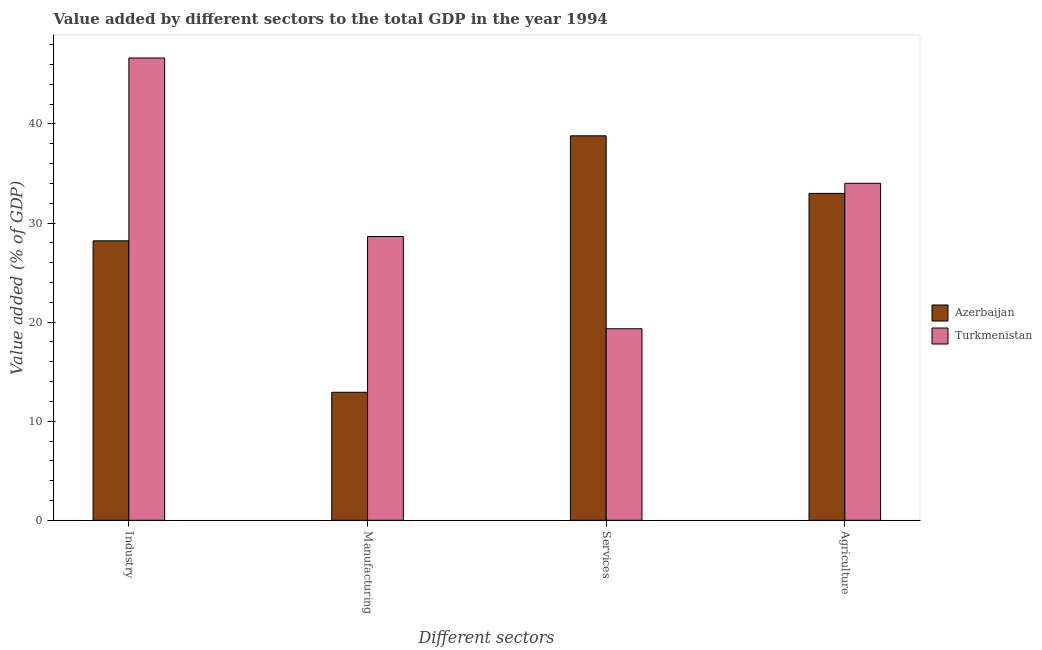How many different coloured bars are there?
Ensure brevity in your answer.  2. How many groups of bars are there?
Provide a short and direct response. 4. Are the number of bars on each tick of the X-axis equal?
Provide a short and direct response. Yes. What is the label of the 1st group of bars from the left?
Offer a terse response. Industry. What is the value added by industrial sector in Turkmenistan?
Keep it short and to the point. 46.66. Across all countries, what is the maximum value added by industrial sector?
Provide a short and direct response. 46.66. Across all countries, what is the minimum value added by agricultural sector?
Your response must be concise. 32.99. In which country was the value added by agricultural sector maximum?
Give a very brief answer. Turkmenistan. In which country was the value added by industrial sector minimum?
Keep it short and to the point. Azerbaijan. What is the total value added by industrial sector in the graph?
Ensure brevity in your answer.  74.86. What is the difference between the value added by agricultural sector in Azerbaijan and that in Turkmenistan?
Ensure brevity in your answer.  -1.02. What is the difference between the value added by agricultural sector in Turkmenistan and the value added by manufacturing sector in Azerbaijan?
Offer a very short reply. 21.09. What is the average value added by agricultural sector per country?
Your answer should be very brief. 33.5. What is the difference between the value added by industrial sector and value added by agricultural sector in Azerbaijan?
Ensure brevity in your answer.  -4.79. In how many countries, is the value added by agricultural sector greater than 22 %?
Keep it short and to the point. 2. What is the ratio of the value added by agricultural sector in Azerbaijan to that in Turkmenistan?
Provide a short and direct response. 0.97. Is the difference between the value added by industrial sector in Turkmenistan and Azerbaijan greater than the difference between the value added by manufacturing sector in Turkmenistan and Azerbaijan?
Offer a terse response. Yes. What is the difference between the highest and the second highest value added by industrial sector?
Ensure brevity in your answer.  18.45. What is the difference between the highest and the lowest value added by services sector?
Keep it short and to the point. 19.47. Is the sum of the value added by agricultural sector in Turkmenistan and Azerbaijan greater than the maximum value added by industrial sector across all countries?
Offer a terse response. Yes. What does the 1st bar from the left in Agriculture represents?
Ensure brevity in your answer.  Azerbaijan. What does the 1st bar from the right in Industry represents?
Your answer should be very brief. Turkmenistan. How many bars are there?
Provide a succinct answer. 8. Are all the bars in the graph horizontal?
Provide a short and direct response. No. How many countries are there in the graph?
Ensure brevity in your answer.  2. Are the values on the major ticks of Y-axis written in scientific E-notation?
Give a very brief answer. No. Where does the legend appear in the graph?
Your answer should be compact. Center right. How many legend labels are there?
Your answer should be very brief. 2. What is the title of the graph?
Give a very brief answer. Value added by different sectors to the total GDP in the year 1994. Does "Kuwait" appear as one of the legend labels in the graph?
Your response must be concise. No. What is the label or title of the X-axis?
Make the answer very short. Different sectors. What is the label or title of the Y-axis?
Offer a very short reply. Value added (% of GDP). What is the Value added (% of GDP) in Azerbaijan in Industry?
Give a very brief answer. 28.2. What is the Value added (% of GDP) in Turkmenistan in Industry?
Make the answer very short. 46.66. What is the Value added (% of GDP) in Azerbaijan in Manufacturing?
Your answer should be very brief. 12.92. What is the Value added (% of GDP) in Turkmenistan in Manufacturing?
Offer a terse response. 28.64. What is the Value added (% of GDP) of Azerbaijan in Services?
Your answer should be compact. 38.8. What is the Value added (% of GDP) in Turkmenistan in Services?
Provide a short and direct response. 19.33. What is the Value added (% of GDP) in Azerbaijan in Agriculture?
Provide a short and direct response. 32.99. What is the Value added (% of GDP) in Turkmenistan in Agriculture?
Your answer should be compact. 34.01. Across all Different sectors, what is the maximum Value added (% of GDP) of Azerbaijan?
Your answer should be very brief. 38.8. Across all Different sectors, what is the maximum Value added (% of GDP) in Turkmenistan?
Your response must be concise. 46.66. Across all Different sectors, what is the minimum Value added (% of GDP) in Azerbaijan?
Provide a succinct answer. 12.92. Across all Different sectors, what is the minimum Value added (% of GDP) in Turkmenistan?
Make the answer very short. 19.33. What is the total Value added (% of GDP) of Azerbaijan in the graph?
Keep it short and to the point. 112.92. What is the total Value added (% of GDP) of Turkmenistan in the graph?
Your response must be concise. 128.64. What is the difference between the Value added (% of GDP) in Azerbaijan in Industry and that in Manufacturing?
Provide a succinct answer. 15.29. What is the difference between the Value added (% of GDP) in Turkmenistan in Industry and that in Manufacturing?
Your response must be concise. 18.02. What is the difference between the Value added (% of GDP) of Azerbaijan in Industry and that in Services?
Your answer should be very brief. -10.6. What is the difference between the Value added (% of GDP) of Turkmenistan in Industry and that in Services?
Your answer should be compact. 27.33. What is the difference between the Value added (% of GDP) of Azerbaijan in Industry and that in Agriculture?
Make the answer very short. -4.79. What is the difference between the Value added (% of GDP) in Turkmenistan in Industry and that in Agriculture?
Your response must be concise. 12.65. What is the difference between the Value added (% of GDP) in Azerbaijan in Manufacturing and that in Services?
Offer a very short reply. -25.89. What is the difference between the Value added (% of GDP) of Turkmenistan in Manufacturing and that in Services?
Offer a terse response. 9.31. What is the difference between the Value added (% of GDP) of Azerbaijan in Manufacturing and that in Agriculture?
Your answer should be very brief. -20.07. What is the difference between the Value added (% of GDP) in Turkmenistan in Manufacturing and that in Agriculture?
Offer a terse response. -5.37. What is the difference between the Value added (% of GDP) of Azerbaijan in Services and that in Agriculture?
Provide a succinct answer. 5.81. What is the difference between the Value added (% of GDP) of Turkmenistan in Services and that in Agriculture?
Ensure brevity in your answer.  -14.68. What is the difference between the Value added (% of GDP) of Azerbaijan in Industry and the Value added (% of GDP) of Turkmenistan in Manufacturing?
Keep it short and to the point. -0.43. What is the difference between the Value added (% of GDP) in Azerbaijan in Industry and the Value added (% of GDP) in Turkmenistan in Services?
Make the answer very short. 8.87. What is the difference between the Value added (% of GDP) of Azerbaijan in Industry and the Value added (% of GDP) of Turkmenistan in Agriculture?
Your answer should be very brief. -5.8. What is the difference between the Value added (% of GDP) in Azerbaijan in Manufacturing and the Value added (% of GDP) in Turkmenistan in Services?
Make the answer very short. -6.41. What is the difference between the Value added (% of GDP) of Azerbaijan in Manufacturing and the Value added (% of GDP) of Turkmenistan in Agriculture?
Your response must be concise. -21.09. What is the difference between the Value added (% of GDP) in Azerbaijan in Services and the Value added (% of GDP) in Turkmenistan in Agriculture?
Keep it short and to the point. 4.79. What is the average Value added (% of GDP) in Azerbaijan per Different sectors?
Offer a very short reply. 28.23. What is the average Value added (% of GDP) in Turkmenistan per Different sectors?
Your response must be concise. 32.16. What is the difference between the Value added (% of GDP) in Azerbaijan and Value added (% of GDP) in Turkmenistan in Industry?
Your answer should be very brief. -18.45. What is the difference between the Value added (% of GDP) in Azerbaijan and Value added (% of GDP) in Turkmenistan in Manufacturing?
Provide a succinct answer. -15.72. What is the difference between the Value added (% of GDP) of Azerbaijan and Value added (% of GDP) of Turkmenistan in Services?
Keep it short and to the point. 19.47. What is the difference between the Value added (% of GDP) in Azerbaijan and Value added (% of GDP) in Turkmenistan in Agriculture?
Your answer should be compact. -1.02. What is the ratio of the Value added (% of GDP) of Azerbaijan in Industry to that in Manufacturing?
Your response must be concise. 2.18. What is the ratio of the Value added (% of GDP) of Turkmenistan in Industry to that in Manufacturing?
Keep it short and to the point. 1.63. What is the ratio of the Value added (% of GDP) of Azerbaijan in Industry to that in Services?
Provide a succinct answer. 0.73. What is the ratio of the Value added (% of GDP) of Turkmenistan in Industry to that in Services?
Provide a short and direct response. 2.41. What is the ratio of the Value added (% of GDP) in Azerbaijan in Industry to that in Agriculture?
Offer a terse response. 0.85. What is the ratio of the Value added (% of GDP) of Turkmenistan in Industry to that in Agriculture?
Your answer should be compact. 1.37. What is the ratio of the Value added (% of GDP) of Azerbaijan in Manufacturing to that in Services?
Ensure brevity in your answer.  0.33. What is the ratio of the Value added (% of GDP) of Turkmenistan in Manufacturing to that in Services?
Keep it short and to the point. 1.48. What is the ratio of the Value added (% of GDP) in Azerbaijan in Manufacturing to that in Agriculture?
Your answer should be very brief. 0.39. What is the ratio of the Value added (% of GDP) in Turkmenistan in Manufacturing to that in Agriculture?
Your answer should be very brief. 0.84. What is the ratio of the Value added (% of GDP) in Azerbaijan in Services to that in Agriculture?
Offer a terse response. 1.18. What is the ratio of the Value added (% of GDP) of Turkmenistan in Services to that in Agriculture?
Offer a terse response. 0.57. What is the difference between the highest and the second highest Value added (% of GDP) in Azerbaijan?
Your answer should be very brief. 5.81. What is the difference between the highest and the second highest Value added (% of GDP) in Turkmenistan?
Provide a succinct answer. 12.65. What is the difference between the highest and the lowest Value added (% of GDP) of Azerbaijan?
Your answer should be very brief. 25.89. What is the difference between the highest and the lowest Value added (% of GDP) of Turkmenistan?
Provide a short and direct response. 27.33. 